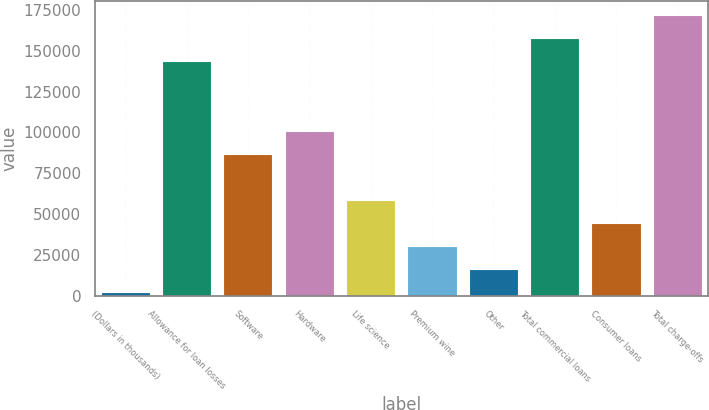Convert chart. <chart><loc_0><loc_0><loc_500><loc_500><bar_chart><fcel>(Dollars in thousands)<fcel>Allowance for loan losses<fcel>Software<fcel>Hardware<fcel>Life science<fcel>Premium wine<fcel>Other<fcel>Total commercial loans<fcel>Consumer loans<fcel>Total charge-offs<nl><fcel>2009<fcel>143570<fcel>86945.6<fcel>101102<fcel>58633.4<fcel>30321.2<fcel>16165.1<fcel>157726<fcel>44477.3<fcel>171882<nl></chart> 